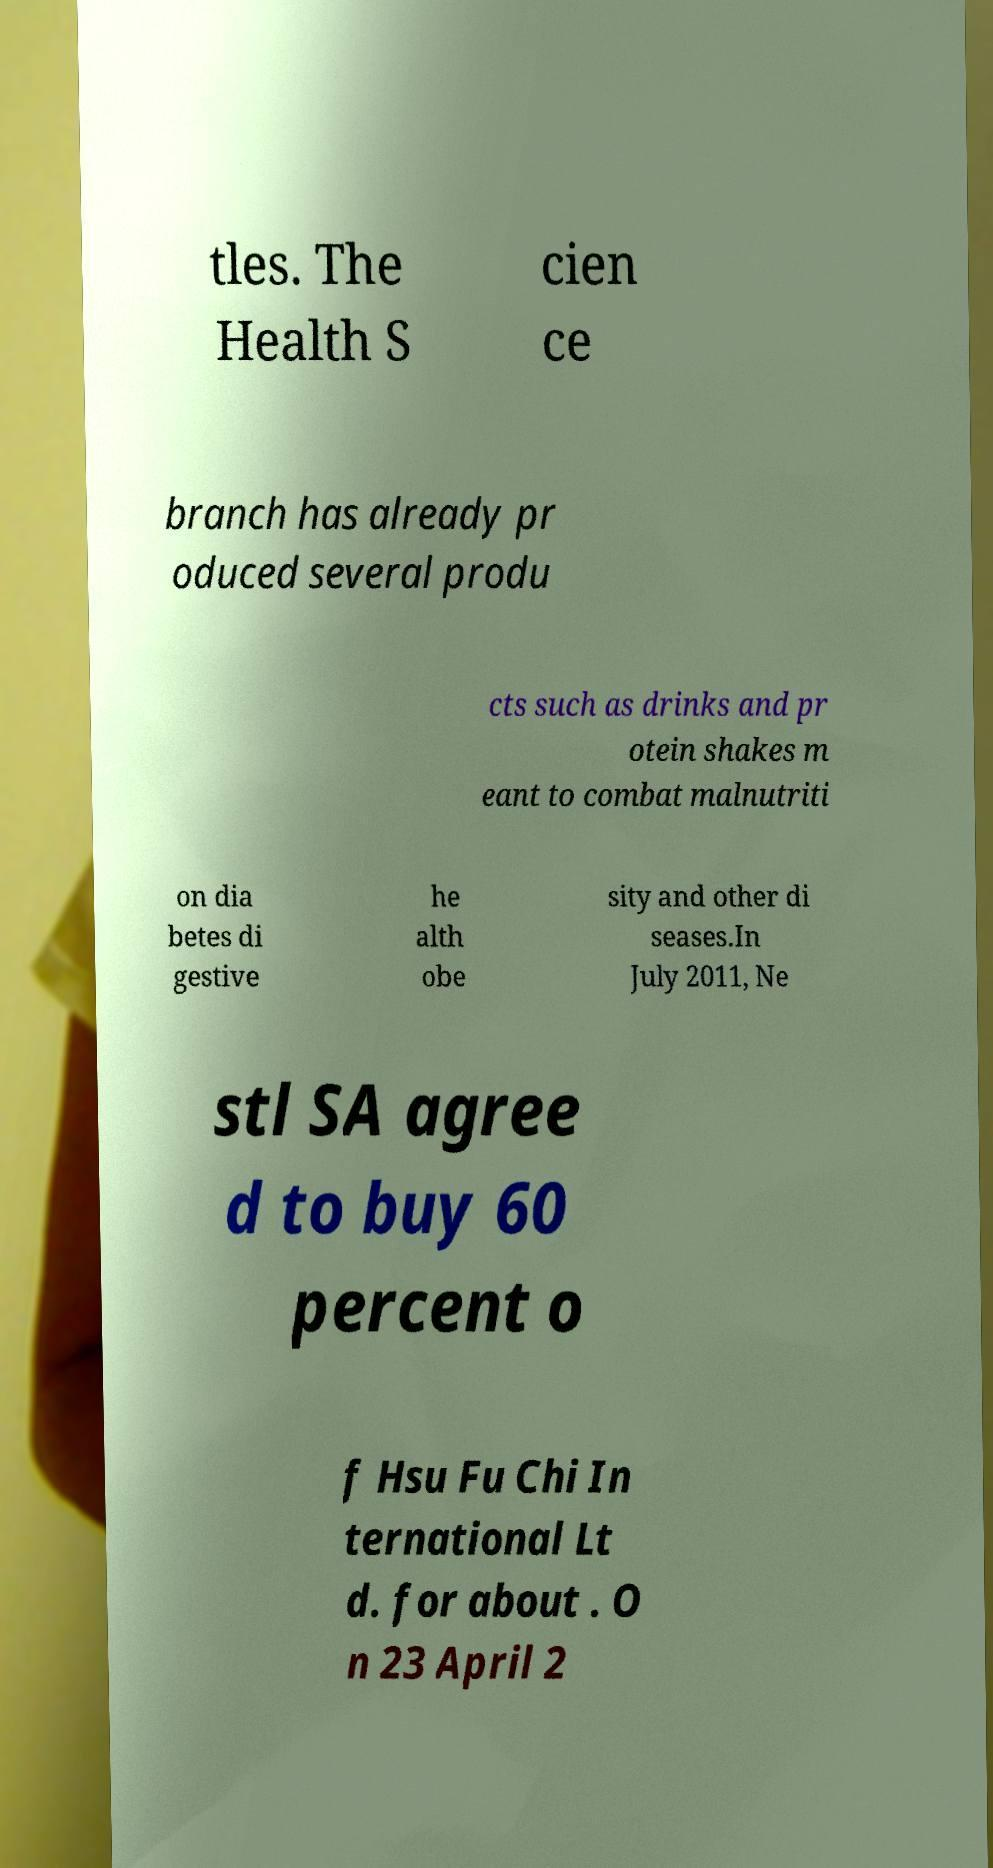Could you extract and type out the text from this image? tles. The Health S cien ce branch has already pr oduced several produ cts such as drinks and pr otein shakes m eant to combat malnutriti on dia betes di gestive he alth obe sity and other di seases.In July 2011, Ne stl SA agree d to buy 60 percent o f Hsu Fu Chi In ternational Lt d. for about . O n 23 April 2 